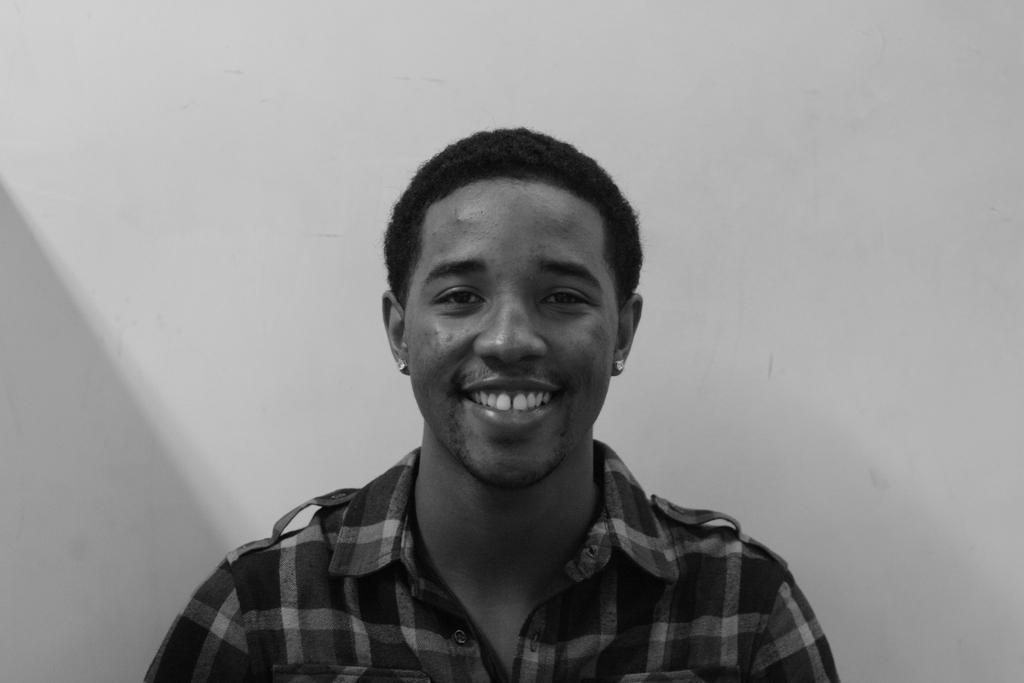Who is the main subject in the image? There is a man in the image. What is the man doing in the image? The man is looking at someone and smiling. What invention can be seen in the man's hand in the image? There is no invention visible in the man's hand in the image. What rhythm is the man tapping out with his foot in the image? There is no indication of the man tapping out a rhythm with his foot in the image. 